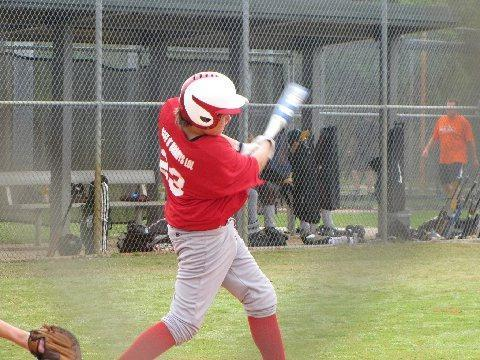Question: what sport are the people in the photo playing?
Choices:
A. Cricket.
B. Soccer.
C. Tennis.
D. Baseball.
Answer with the letter. Answer: D Question: what colors are in the batter's uniform?
Choices:
A. Red.
B. Red and White.
C. Green.
D. Yellow.
Answer with the letter. Answer: B Question: what color shirt is the man in the far right wearing?
Choices:
A. Orange.
B. Blue.
C. Yellow.
D. Black.
Answer with the letter. Answer: A Question: what color is the metal fence?
Choices:
A. Silver.
B. White.
C. Gold.
D. Black.
Answer with the letter. Answer: A Question: where are the people in this photo?
Choices:
A. In the zoo.
B. Baseball Field.
C. At the mall.
D. In school.
Answer with the letter. Answer: B Question: why are the people at the baseball field?
Choices:
A. To celebrate.
B. To play.
C. Game.
D. To compete.
Answer with the letter. Answer: C Question: what number player is up to bat?
Choices:
A. 11.
B. 23.
C. 13.
D. 21.
Answer with the letter. Answer: B 